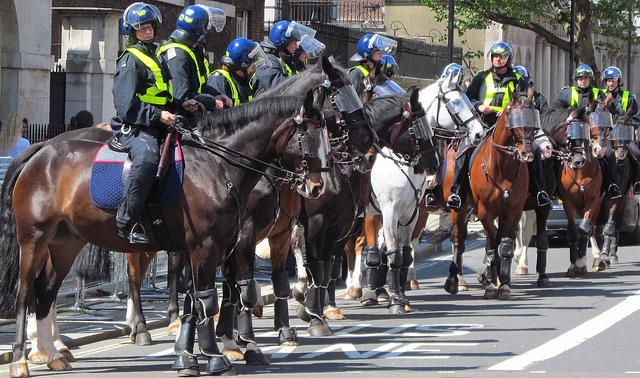Why do the horses wear leg coverings? Please explain your reasoning. armor. Horses are part of a police unit and wear stuff on legs to give them added protection. 